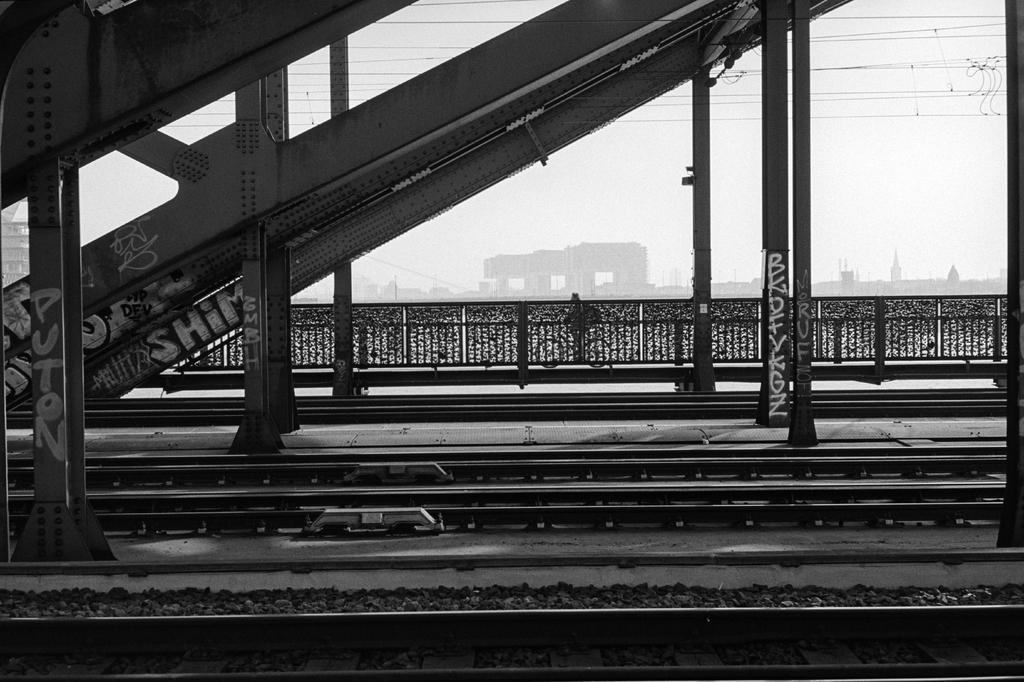What can be seen on the ground in the image? There are tracks in the image. What is visible in the background of the image? There is a railing, buildings, and electric wires in the background of the image. What is the color scheme of the image? The image is in black and white. What type of notebook is lying on the tracks in the image? There is no notebook present in the image; it only features tracks, a railing, buildings, electric wires, and a black and white color scheme. Can you see a kettle boiling in the background of the image? There is no kettle present in the image; it only features tracks, a railing, buildings, electric wires, and a black and white color scheme. 